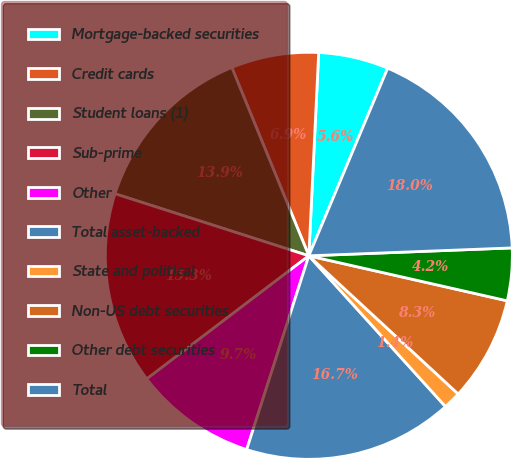<chart> <loc_0><loc_0><loc_500><loc_500><pie_chart><fcel>Mortgage-backed securities<fcel>Credit cards<fcel>Student loans (1)<fcel>Sub-prime<fcel>Other<fcel>Total asset-backed<fcel>State and political<fcel>Non-US debt securities<fcel>Other debt securities<fcel>Total<nl><fcel>5.56%<fcel>6.95%<fcel>13.89%<fcel>15.27%<fcel>9.72%<fcel>16.66%<fcel>1.4%<fcel>8.33%<fcel>4.17%<fcel>18.05%<nl></chart> 